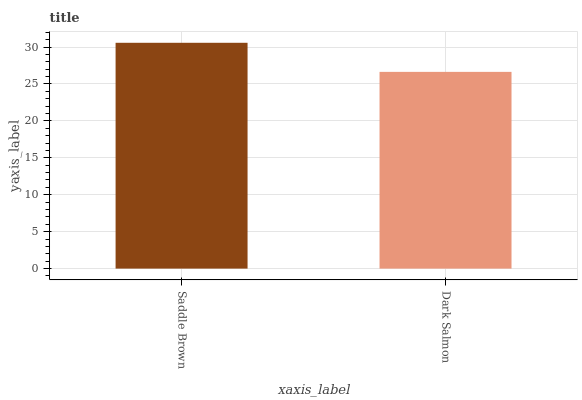Is Dark Salmon the minimum?
Answer yes or no. Yes. Is Saddle Brown the maximum?
Answer yes or no. Yes. Is Dark Salmon the maximum?
Answer yes or no. No. Is Saddle Brown greater than Dark Salmon?
Answer yes or no. Yes. Is Dark Salmon less than Saddle Brown?
Answer yes or no. Yes. Is Dark Salmon greater than Saddle Brown?
Answer yes or no. No. Is Saddle Brown less than Dark Salmon?
Answer yes or no. No. Is Saddle Brown the high median?
Answer yes or no. Yes. Is Dark Salmon the low median?
Answer yes or no. Yes. Is Dark Salmon the high median?
Answer yes or no. No. Is Saddle Brown the low median?
Answer yes or no. No. 